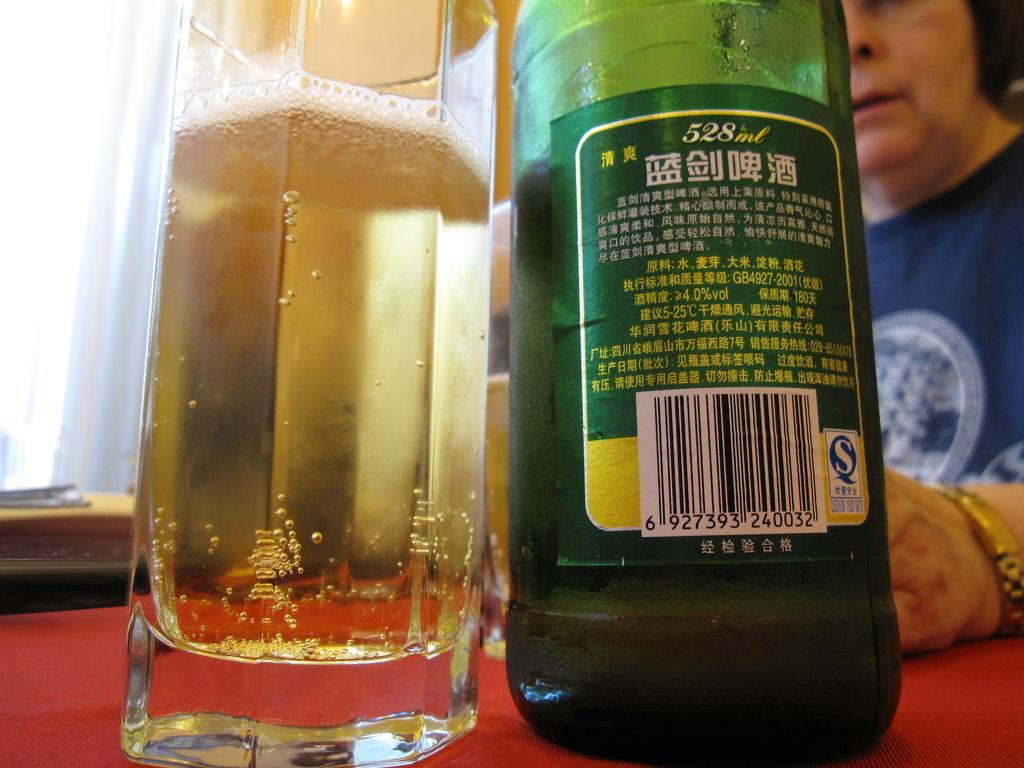<image>
Render a clear and concise summary of the photo. a 528ml bottle is sitting on a table with a red table cloth 